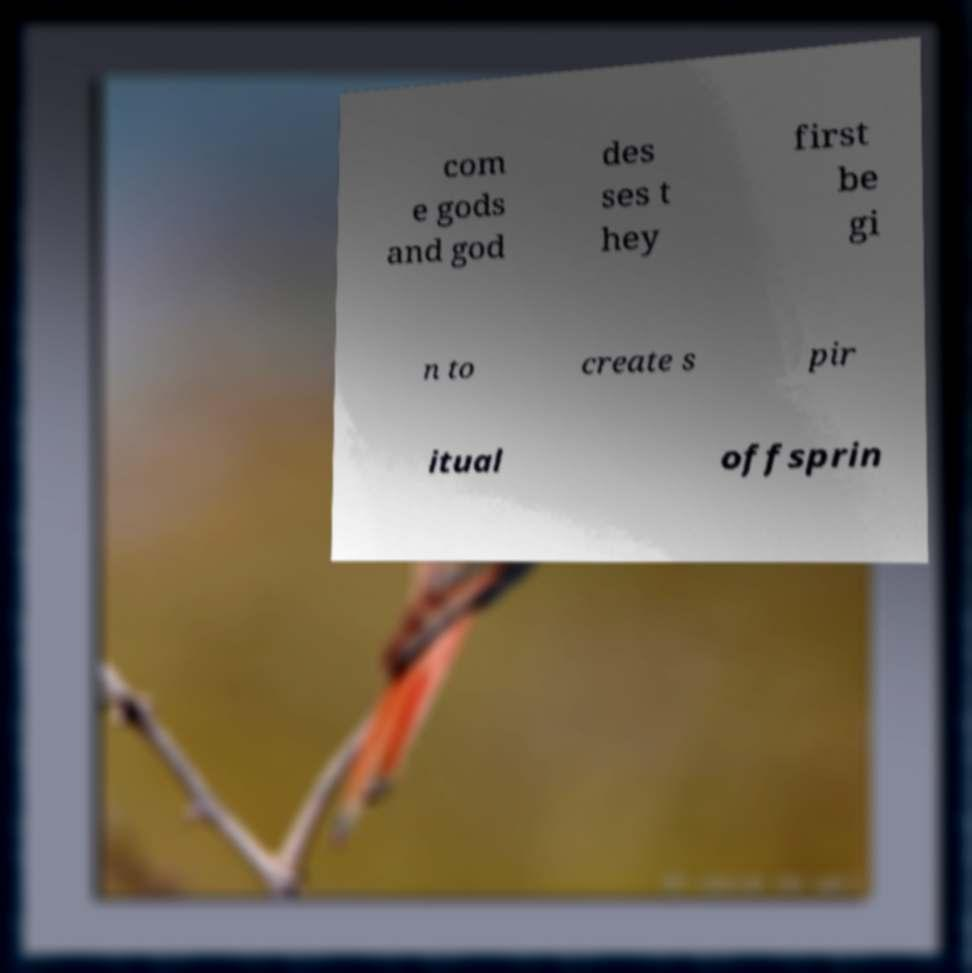Could you extract and type out the text from this image? com e gods and god des ses t hey first be gi n to create s pir itual offsprin 